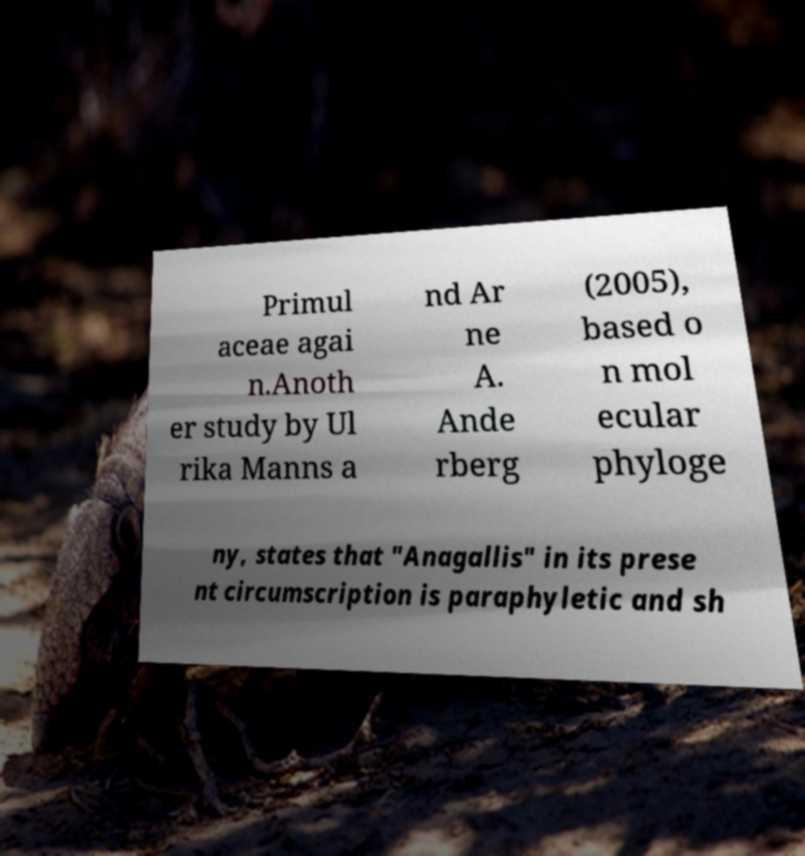There's text embedded in this image that I need extracted. Can you transcribe it verbatim? Primul aceae agai n.Anoth er study by Ul rika Manns a nd Ar ne A. Ande rberg (2005), based o n mol ecular phyloge ny, states that "Anagallis" in its prese nt circumscription is paraphyletic and sh 